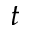<formula> <loc_0><loc_0><loc_500><loc_500>t</formula> 